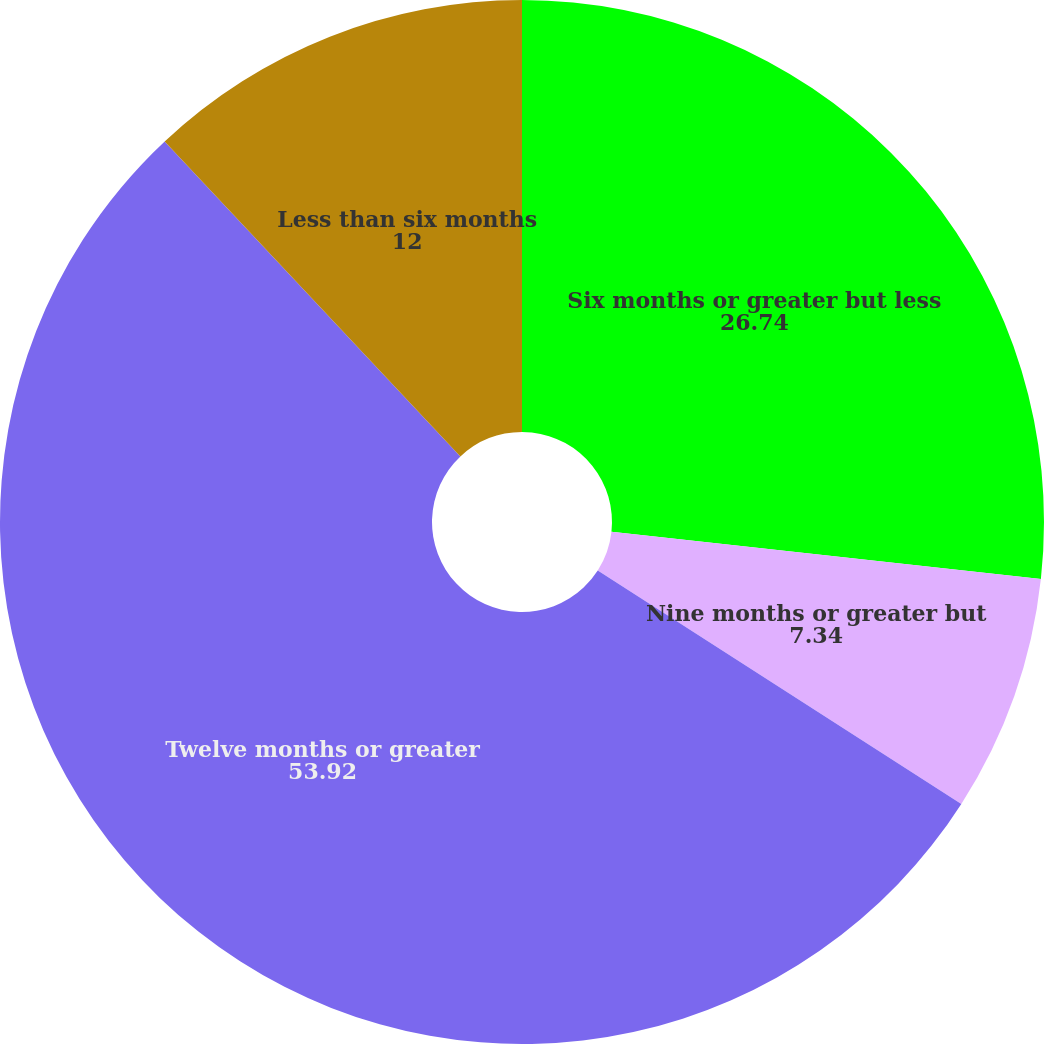<chart> <loc_0><loc_0><loc_500><loc_500><pie_chart><fcel>Six months or greater but less<fcel>Nine months or greater but<fcel>Twelve months or greater<fcel>Less than six months<nl><fcel>26.74%<fcel>7.34%<fcel>53.92%<fcel>12.0%<nl></chart> 